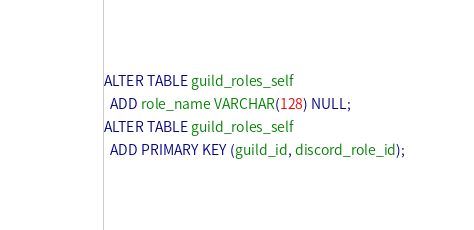Convert code to text. <code><loc_0><loc_0><loc_500><loc_500><_SQL_>ALTER TABLE guild_roles_self
  ADD role_name VARCHAR(128) NULL;
ALTER TABLE guild_roles_self
  ADD PRIMARY KEY (guild_id, discord_role_id);</code> 